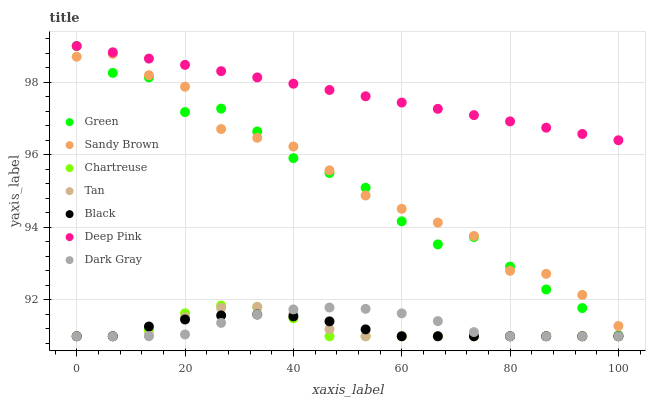Does Chartreuse have the minimum area under the curve?
Answer yes or no. Yes. Does Deep Pink have the maximum area under the curve?
Answer yes or no. Yes. Does Dark Gray have the minimum area under the curve?
Answer yes or no. No. Does Dark Gray have the maximum area under the curve?
Answer yes or no. No. Is Deep Pink the smoothest?
Answer yes or no. Yes. Is Green the roughest?
Answer yes or no. Yes. Is Dark Gray the smoothest?
Answer yes or no. No. Is Dark Gray the roughest?
Answer yes or no. No. Does Dark Gray have the lowest value?
Answer yes or no. Yes. Does Green have the lowest value?
Answer yes or no. No. Does Green have the highest value?
Answer yes or no. Yes. Does Dark Gray have the highest value?
Answer yes or no. No. Is Chartreuse less than Deep Pink?
Answer yes or no. Yes. Is Sandy Brown greater than Black?
Answer yes or no. Yes. Does Black intersect Chartreuse?
Answer yes or no. Yes. Is Black less than Chartreuse?
Answer yes or no. No. Is Black greater than Chartreuse?
Answer yes or no. No. Does Chartreuse intersect Deep Pink?
Answer yes or no. No. 